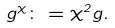<formula> <loc_0><loc_0><loc_500><loc_500>g ^ { \chi } \colon = { \chi ^ { 2 } } g .</formula> 